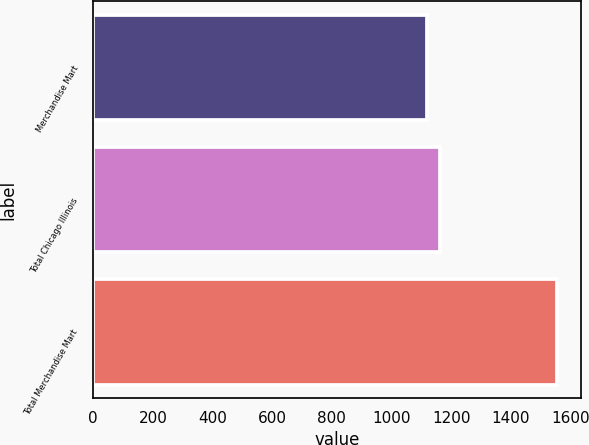<chart> <loc_0><loc_0><loc_500><loc_500><bar_chart><fcel>Merchandise Mart<fcel>Total Chicago Illinois<fcel>Total Merchandise Mart<nl><fcel>1119<fcel>1162.7<fcel>1556<nl></chart> 